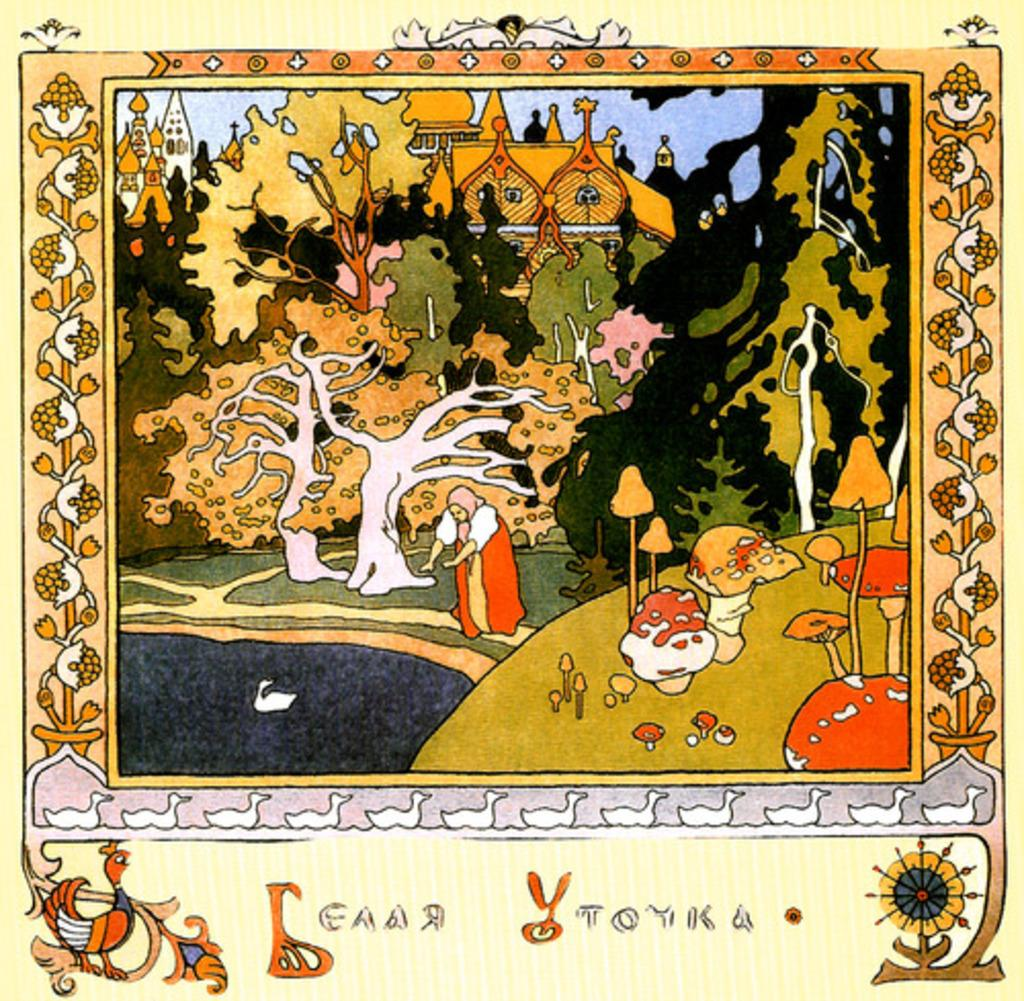What type of artwork is depicted in the image? The image is a painting. What feature surrounds the main subject of the painting? There is a border in the painting. What type of natural elements can be seen in the painting? There are trees in the painting. What type of man-made structures are present in the painting? There are buildings in the painting. Can you describe any other elements in the painting? There are other unspecified elements in the painting. Where is the drawer located in the painting? There is no drawer present in the painting. What type of bread is being used to create the border in the painting? The border in the painting is not made of bread; it is a separate feature from the main subjects and objects in the painting. 